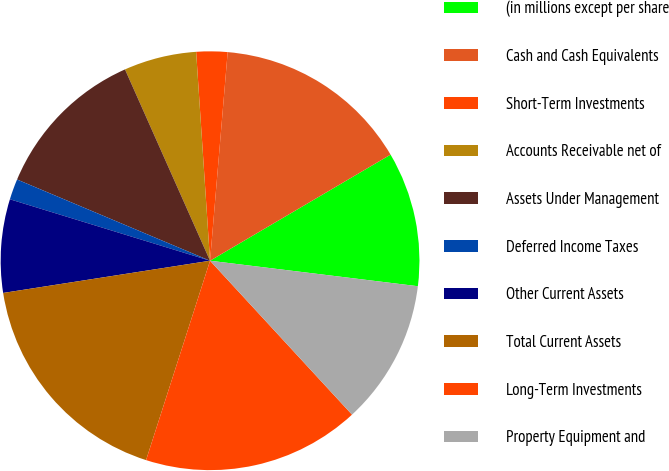Convert chart. <chart><loc_0><loc_0><loc_500><loc_500><pie_chart><fcel>(in millions except per share<fcel>Cash and Cash Equivalents<fcel>Short-Term Investments<fcel>Accounts Receivable net of<fcel>Assets Under Management<fcel>Deferred Income Taxes<fcel>Other Current Assets<fcel>Total Current Assets<fcel>Long-Term Investments<fcel>Property Equipment and<nl><fcel>10.4%<fcel>15.2%<fcel>2.4%<fcel>5.6%<fcel>12.0%<fcel>1.6%<fcel>7.2%<fcel>17.6%<fcel>16.8%<fcel>11.2%<nl></chart> 